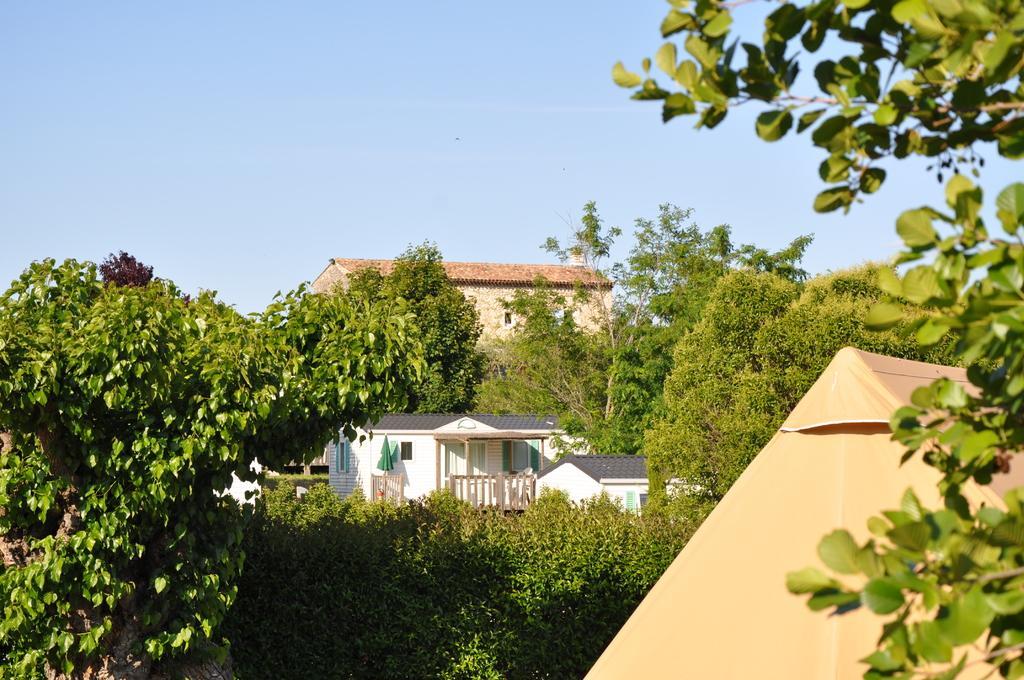Please provide a concise description of this image. In this image I can see many trees and the houses. In the background I can see the sky. 